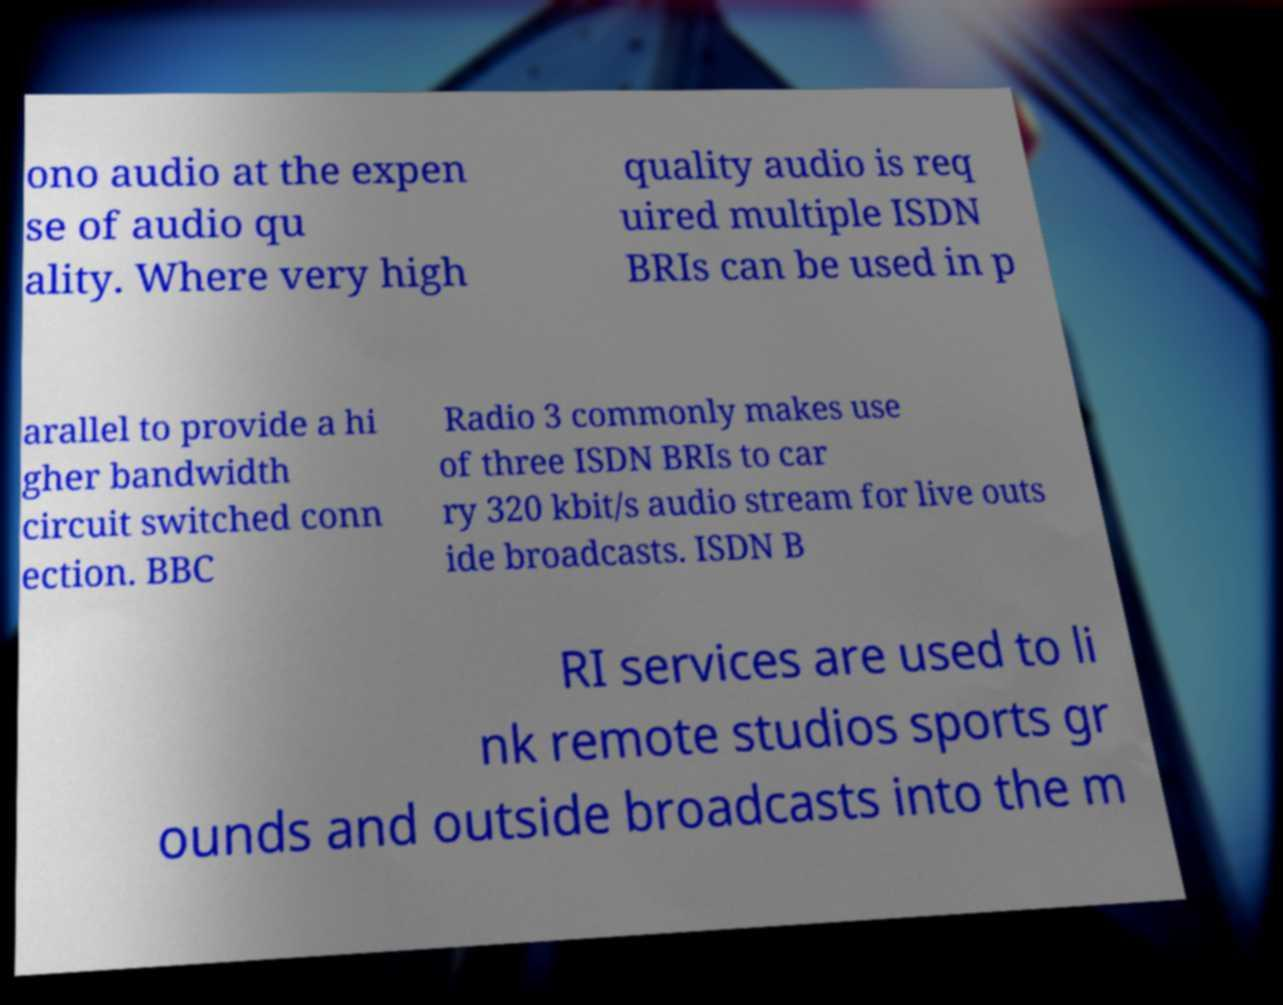There's text embedded in this image that I need extracted. Can you transcribe it verbatim? ono audio at the expen se of audio qu ality. Where very high quality audio is req uired multiple ISDN BRIs can be used in p arallel to provide a hi gher bandwidth circuit switched conn ection. BBC Radio 3 commonly makes use of three ISDN BRIs to car ry 320 kbit/s audio stream for live outs ide broadcasts. ISDN B RI services are used to li nk remote studios sports gr ounds and outside broadcasts into the m 